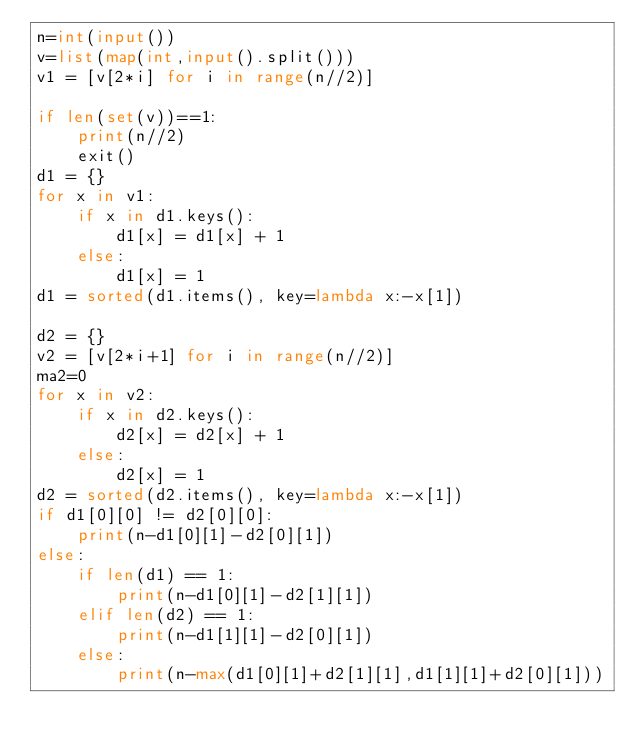<code> <loc_0><loc_0><loc_500><loc_500><_Python_>n=int(input())
v=list(map(int,input().split()))
v1 = [v[2*i] for i in range(n//2)]

if len(set(v))==1:
    print(n//2)
    exit()
d1 = {}
for x in v1:
    if x in d1.keys():
        d1[x] = d1[x] + 1
    else:
        d1[x] = 1
d1 = sorted(d1.items(), key=lambda x:-x[1])

d2 = {}
v2 = [v[2*i+1] for i in range(n//2)]
ma2=0
for x in v2:
    if x in d2.keys():
        d2[x] = d2[x] + 1
    else:
        d2[x] = 1
d2 = sorted(d2.items(), key=lambda x:-x[1])
if d1[0][0] != d2[0][0]:
    print(n-d1[0][1]-d2[0][1])
else:
    if len(d1) == 1:
        print(n-d1[0][1]-d2[1][1])
    elif len(d2) == 1:
        print(n-d1[1][1]-d2[0][1])
    else:
        print(n-max(d1[0][1]+d2[1][1],d1[1][1]+d2[0][1]))</code> 